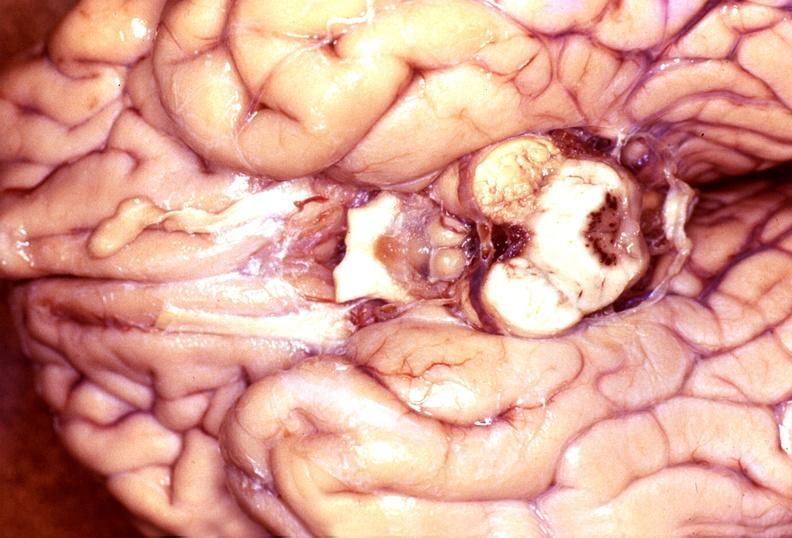what does this image show?
Answer the question using a single word or phrase. Wernicke 's encephalopathy 